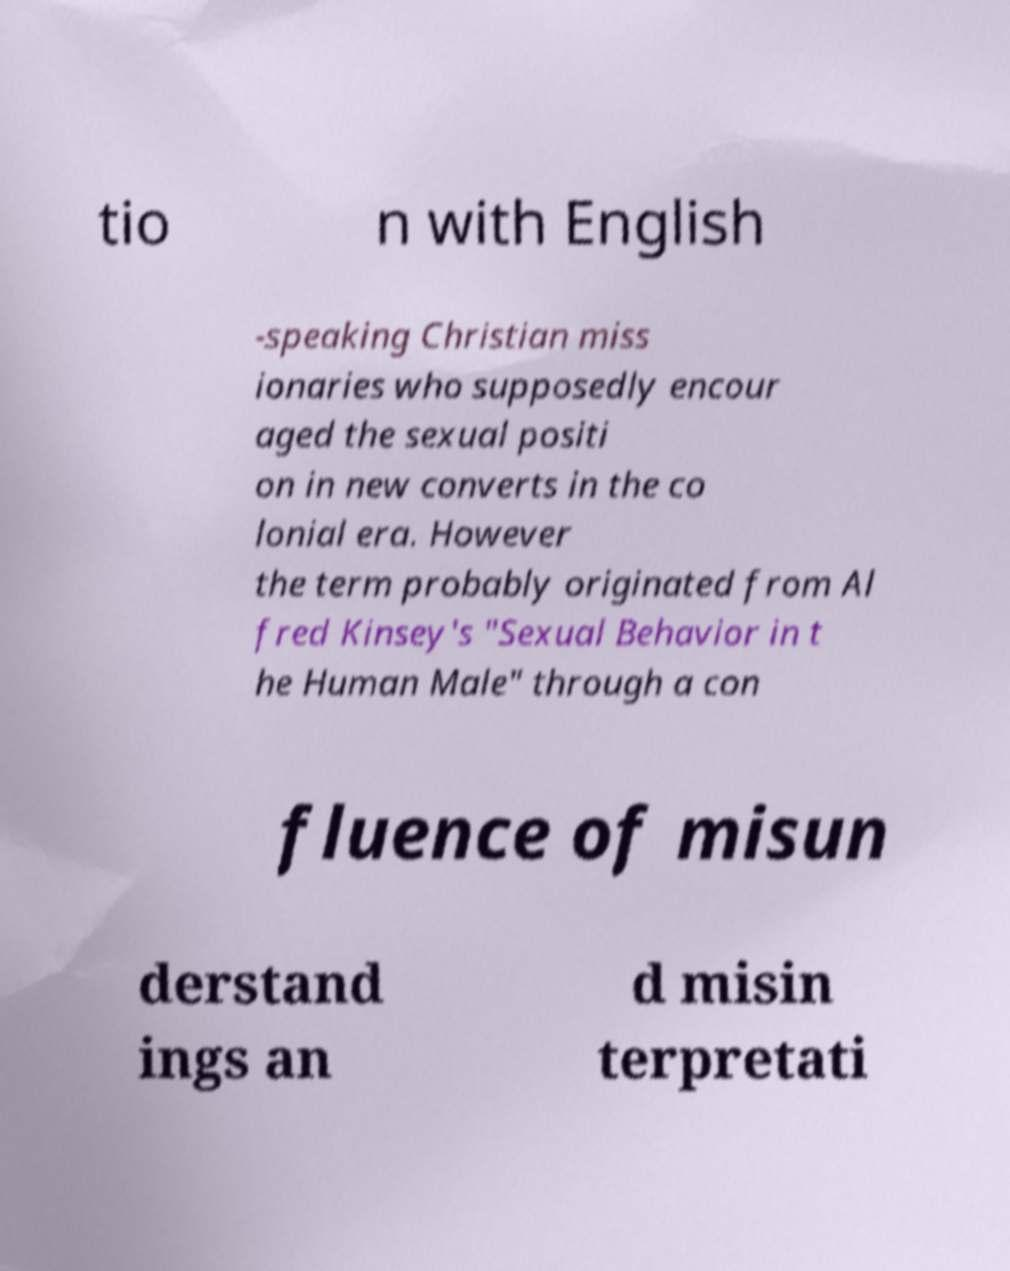Can you read and provide the text displayed in the image?This photo seems to have some interesting text. Can you extract and type it out for me? tio n with English -speaking Christian miss ionaries who supposedly encour aged the sexual positi on in new converts in the co lonial era. However the term probably originated from Al fred Kinsey's "Sexual Behavior in t he Human Male" through a con fluence of misun derstand ings an d misin terpretati 